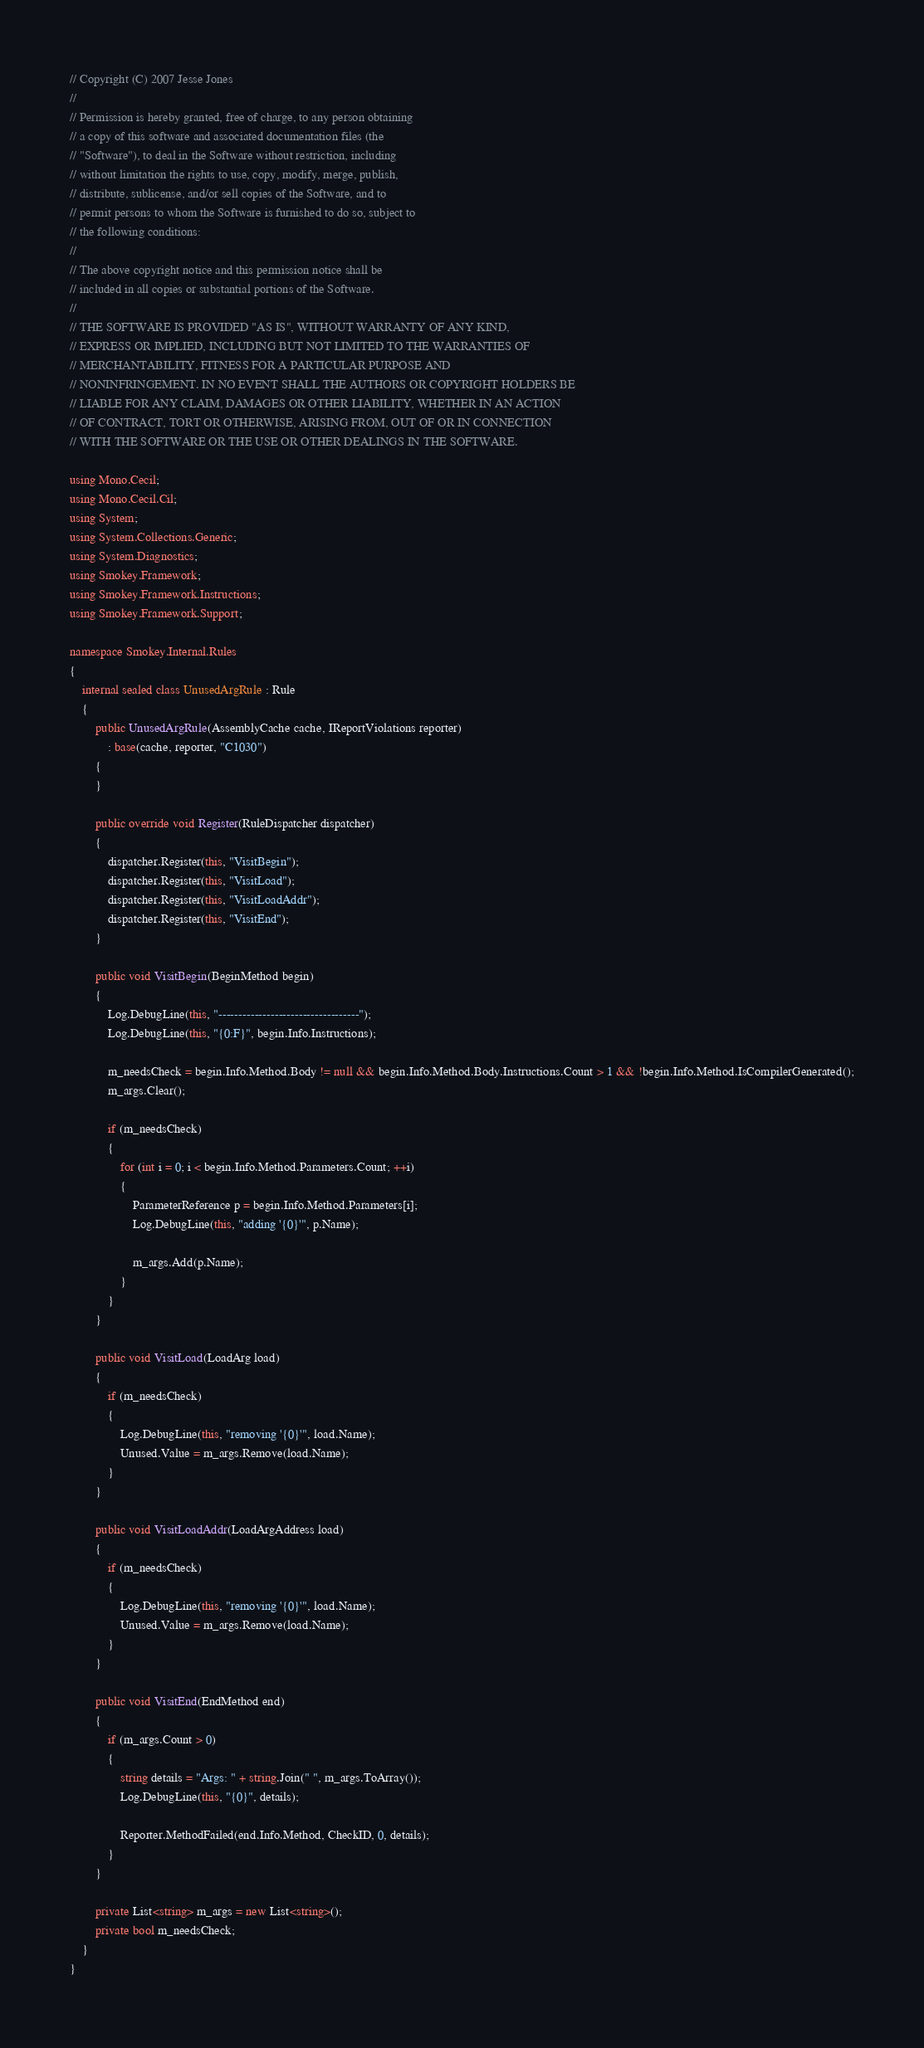Convert code to text. <code><loc_0><loc_0><loc_500><loc_500><_C#_>// Copyright (C) 2007 Jesse Jones
//
// Permission is hereby granted, free of charge, to any person obtaining
// a copy of this software and associated documentation files (the
// "Software"), to deal in the Software without restriction, including
// without limitation the rights to use, copy, modify, merge, publish,
// distribute, sublicense, and/or sell copies of the Software, and to
// permit persons to whom the Software is furnished to do so, subject to
// the following conditions:
// 
// The above copyright notice and this permission notice shall be
// included in all copies or substantial portions of the Software.
// 
// THE SOFTWARE IS PROVIDED "AS IS", WITHOUT WARRANTY OF ANY KIND,
// EXPRESS OR IMPLIED, INCLUDING BUT NOT LIMITED TO THE WARRANTIES OF
// MERCHANTABILITY, FITNESS FOR A PARTICULAR PURPOSE AND
// NONINFRINGEMENT. IN NO EVENT SHALL THE AUTHORS OR COPYRIGHT HOLDERS BE
// LIABLE FOR ANY CLAIM, DAMAGES OR OTHER LIABILITY, WHETHER IN AN ACTION
// OF CONTRACT, TORT OR OTHERWISE, ARISING FROM, OUT OF OR IN CONNECTION
// WITH THE SOFTWARE OR THE USE OR OTHER DEALINGS IN THE SOFTWARE.

using Mono.Cecil;
using Mono.Cecil.Cil;
using System;
using System.Collections.Generic;
using System.Diagnostics;
using Smokey.Framework;
using Smokey.Framework.Instructions;
using Smokey.Framework.Support;

namespace Smokey.Internal.Rules
{	
	internal sealed class UnusedArgRule : Rule
	{				
		public UnusedArgRule(AssemblyCache cache, IReportViolations reporter) 
			: base(cache, reporter, "C1030")
		{
		}
				
		public override void Register(RuleDispatcher dispatcher) 
		{
			dispatcher.Register(this, "VisitBegin");
			dispatcher.Register(this, "VisitLoad");
			dispatcher.Register(this, "VisitLoadAddr");
			dispatcher.Register(this, "VisitEnd");
		}
		
		public void VisitBegin(BeginMethod begin)
		{
			Log.DebugLine(this, "-----------------------------------"); 
			Log.DebugLine(this, "{0:F}", begin.Info.Instructions);				

			m_needsCheck = begin.Info.Method.Body != null && begin.Info.Method.Body.Instructions.Count > 1 && !begin.Info.Method.IsCompilerGenerated();
			m_args.Clear();

			if (m_needsCheck)
			{
				for (int i = 0; i < begin.Info.Method.Parameters.Count; ++i)
				{
					ParameterReference p = begin.Info.Method.Parameters[i];
					Log.DebugLine(this, "adding '{0}'", p.Name);				
				
					m_args.Add(p.Name);
				}
			}
		}
		
		public void VisitLoad(LoadArg load)
		{
			if (m_needsCheck)
			{
				Log.DebugLine(this, "removing '{0}'", load.Name);				
				Unused.Value = m_args.Remove(load.Name);
			}
		}

		public void VisitLoadAddr(LoadArgAddress load)
		{
			if (m_needsCheck)
			{
				Log.DebugLine(this, "removing '{0}'", load.Name);				
				Unused.Value = m_args.Remove(load.Name);
			}
		}

		public void VisitEnd(EndMethod end)
		{
			if (m_args.Count > 0)
			{
				string details = "Args: " + string.Join(" ", m_args.ToArray());
				Log.DebugLine(this, "{0}", details);				

				Reporter.MethodFailed(end.Info.Method, CheckID, 0, details);
			}
		}
						
		private List<string> m_args = new List<string>();
		private bool m_needsCheck;
	}
}
</code> 